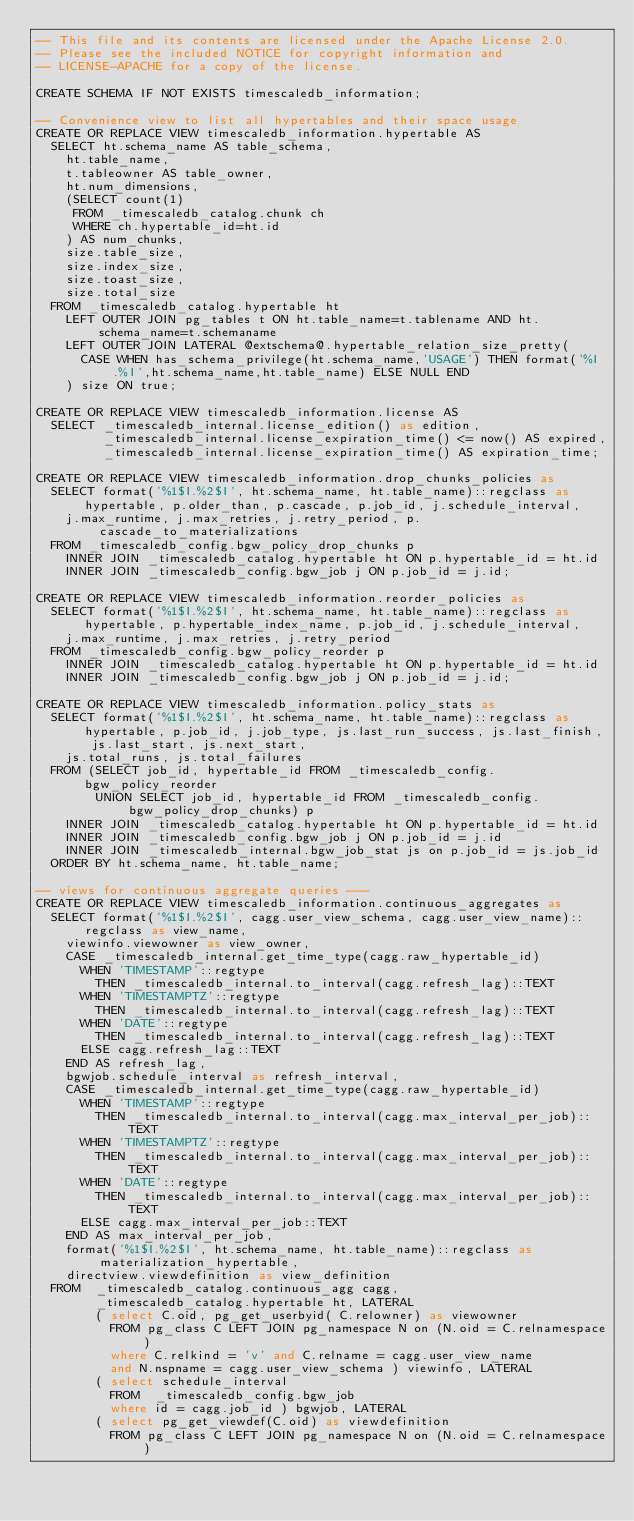<code> <loc_0><loc_0><loc_500><loc_500><_SQL_>-- This file and its contents are licensed under the Apache License 2.0.
-- Please see the included NOTICE for copyright information and
-- LICENSE-APACHE for a copy of the license.

CREATE SCHEMA IF NOT EXISTS timescaledb_information;

-- Convenience view to list all hypertables and their space usage
CREATE OR REPLACE VIEW timescaledb_information.hypertable AS
  SELECT ht.schema_name AS table_schema,
    ht.table_name,
    t.tableowner AS table_owner,
    ht.num_dimensions,
    (SELECT count(1)
     FROM _timescaledb_catalog.chunk ch
     WHERE ch.hypertable_id=ht.id
    ) AS num_chunks,
    size.table_size,
    size.index_size,
    size.toast_size,
    size.total_size
  FROM _timescaledb_catalog.hypertable ht
    LEFT OUTER JOIN pg_tables t ON ht.table_name=t.tablename AND ht.schema_name=t.schemaname
    LEFT OUTER JOIN LATERAL @extschema@.hypertable_relation_size_pretty(
      CASE WHEN has_schema_privilege(ht.schema_name,'USAGE') THEN format('%I.%I',ht.schema_name,ht.table_name) ELSE NULL END
    ) size ON true;

CREATE OR REPLACE VIEW timescaledb_information.license AS
  SELECT _timescaledb_internal.license_edition() as edition,
         _timescaledb_internal.license_expiration_time() <= now() AS expired,
         _timescaledb_internal.license_expiration_time() AS expiration_time;

CREATE OR REPLACE VIEW timescaledb_information.drop_chunks_policies as
  SELECT format('%1$I.%2$I', ht.schema_name, ht.table_name)::regclass as hypertable, p.older_than, p.cascade, p.job_id, j.schedule_interval,
    j.max_runtime, j.max_retries, j.retry_period, p.cascade_to_materializations
  FROM _timescaledb_config.bgw_policy_drop_chunks p
    INNER JOIN _timescaledb_catalog.hypertable ht ON p.hypertable_id = ht.id
    INNER JOIN _timescaledb_config.bgw_job j ON p.job_id = j.id;

CREATE OR REPLACE VIEW timescaledb_information.reorder_policies as
  SELECT format('%1$I.%2$I', ht.schema_name, ht.table_name)::regclass as hypertable, p.hypertable_index_name, p.job_id, j.schedule_interval,
    j.max_runtime, j.max_retries, j.retry_period
  FROM _timescaledb_config.bgw_policy_reorder p
    INNER JOIN _timescaledb_catalog.hypertable ht ON p.hypertable_id = ht.id
    INNER JOIN _timescaledb_config.bgw_job j ON p.job_id = j.id;

CREATE OR REPLACE VIEW timescaledb_information.policy_stats as
  SELECT format('%1$I.%2$I', ht.schema_name, ht.table_name)::regclass as hypertable, p.job_id, j.job_type, js.last_run_success, js.last_finish, js.last_start, js.next_start,
    js.total_runs, js.total_failures
  FROM (SELECT job_id, hypertable_id FROM _timescaledb_config.bgw_policy_reorder
        UNION SELECT job_id, hypertable_id FROM _timescaledb_config.bgw_policy_drop_chunks) p
    INNER JOIN _timescaledb_catalog.hypertable ht ON p.hypertable_id = ht.id
    INNER JOIN _timescaledb_config.bgw_job j ON p.job_id = j.id
    INNER JOIN _timescaledb_internal.bgw_job_stat js on p.job_id = js.job_id
  ORDER BY ht.schema_name, ht.table_name;

-- views for continuous aggregate queries ---
CREATE OR REPLACE VIEW timescaledb_information.continuous_aggregates as
  SELECT format('%1$I.%2$I', cagg.user_view_schema, cagg.user_view_name)::regclass as view_name,
    viewinfo.viewowner as view_owner,
    CASE _timescaledb_internal.get_time_type(cagg.raw_hypertable_id)
      WHEN 'TIMESTAMP'::regtype
        THEN _timescaledb_internal.to_interval(cagg.refresh_lag)::TEXT
      WHEN 'TIMESTAMPTZ'::regtype
        THEN _timescaledb_internal.to_interval(cagg.refresh_lag)::TEXT
      WHEN 'DATE'::regtype
        THEN _timescaledb_internal.to_interval(cagg.refresh_lag)::TEXT
      ELSE cagg.refresh_lag::TEXT
    END AS refresh_lag,
    bgwjob.schedule_interval as refresh_interval,
    CASE _timescaledb_internal.get_time_type(cagg.raw_hypertable_id)
      WHEN 'TIMESTAMP'::regtype
        THEN _timescaledb_internal.to_interval(cagg.max_interval_per_job)::TEXT
      WHEN 'TIMESTAMPTZ'::regtype
        THEN _timescaledb_internal.to_interval(cagg.max_interval_per_job)::TEXT
      WHEN 'DATE'::regtype
        THEN _timescaledb_internal.to_interval(cagg.max_interval_per_job)::TEXT
      ELSE cagg.max_interval_per_job::TEXT
    END AS max_interval_per_job,
    format('%1$I.%2$I', ht.schema_name, ht.table_name)::regclass as materialization_hypertable,
    directview.viewdefinition as view_definition
  FROM  _timescaledb_catalog.continuous_agg cagg,
        _timescaledb_catalog.hypertable ht, LATERAL
        ( select C.oid, pg_get_userbyid( C.relowner) as viewowner
          FROM pg_class C LEFT JOIN pg_namespace N on (N.oid = C.relnamespace)
          where C.relkind = 'v' and C.relname = cagg.user_view_name
          and N.nspname = cagg.user_view_schema ) viewinfo, LATERAL
        ( select schedule_interval
          FROM  _timescaledb_config.bgw_job
          where id = cagg.job_id ) bgwjob, LATERAL
        ( select pg_get_viewdef(C.oid) as viewdefinition
          FROM pg_class C LEFT JOIN pg_namespace N on (N.oid = C.relnamespace)</code> 